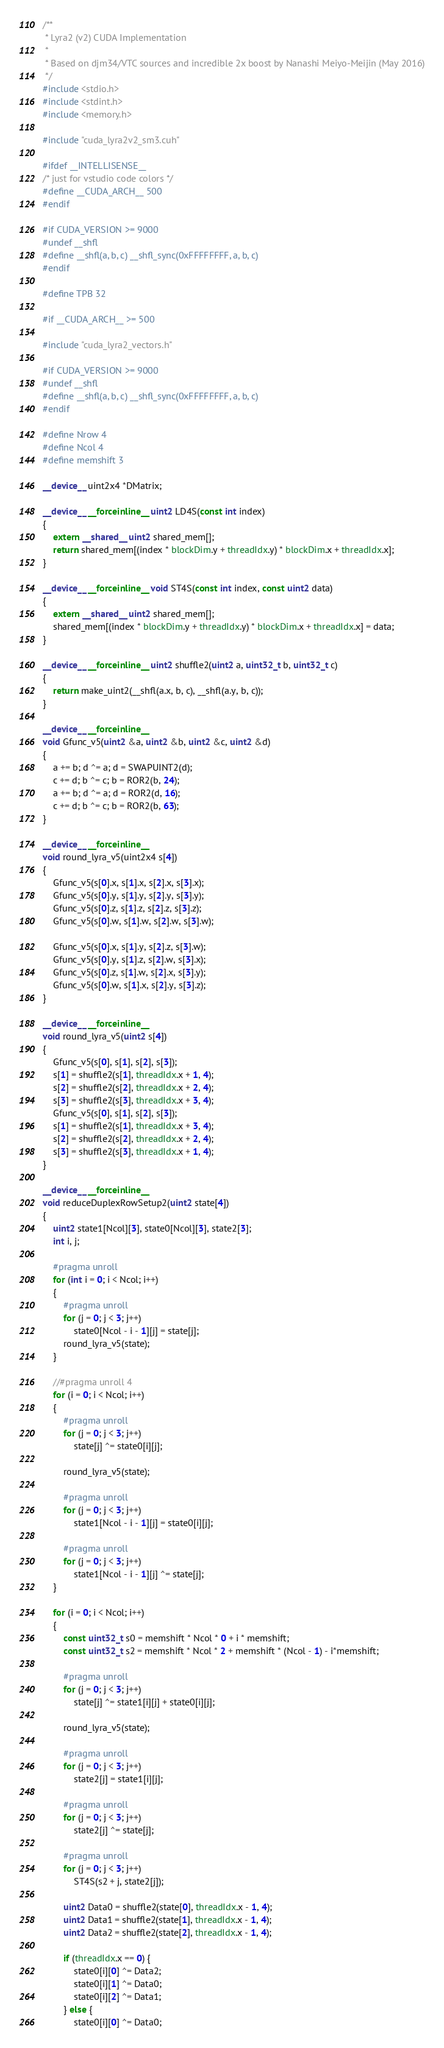Convert code to text. <code><loc_0><loc_0><loc_500><loc_500><_Cuda_>/**
 * Lyra2 (v2) CUDA Implementation
 *
 * Based on djm34/VTC sources and incredible 2x boost by Nanashi Meiyo-Meijin (May 2016)
 */
#include <stdio.h>
#include <stdint.h>
#include <memory.h>

#include "cuda_lyra2v2_sm3.cuh"

#ifdef __INTELLISENSE__
/* just for vstudio code colors */
#define __CUDA_ARCH__ 500
#endif

#if CUDA_VERSION >= 9000
#undef __shfl
#define __shfl(a, b, c) __shfl_sync(0xFFFFFFFF, a, b, c)
#endif

#define TPB 32

#if __CUDA_ARCH__ >= 500

#include "cuda_lyra2_vectors.h"

#if CUDA_VERSION >= 9000
#undef __shfl
#define __shfl(a, b, c) __shfl_sync(0xFFFFFFFF, a, b, c)
#endif

#define Nrow 4
#define Ncol 4
#define memshift 3

__device__ uint2x4 *DMatrix;

__device__ __forceinline__ uint2 LD4S(const int index)
{
	extern __shared__ uint2 shared_mem[];
	return shared_mem[(index * blockDim.y + threadIdx.y) * blockDim.x + threadIdx.x];
}

__device__ __forceinline__ void ST4S(const int index, const uint2 data)
{
	extern __shared__ uint2 shared_mem[];
	shared_mem[(index * blockDim.y + threadIdx.y) * blockDim.x + threadIdx.x] = data;
}

__device__ __forceinline__ uint2 shuffle2(uint2 a, uint32_t b, uint32_t c)
{
	return make_uint2(__shfl(a.x, b, c), __shfl(a.y, b, c));
}

__device__ __forceinline__
void Gfunc_v5(uint2 &a, uint2 &b, uint2 &c, uint2 &d)
{
	a += b; d ^= a; d = SWAPUINT2(d);
	c += d; b ^= c; b = ROR2(b, 24);
	a += b; d ^= a; d = ROR2(d, 16);
	c += d; b ^= c; b = ROR2(b, 63);
}

__device__ __forceinline__
void round_lyra_v5(uint2x4 s[4])
{
	Gfunc_v5(s[0].x, s[1].x, s[2].x, s[3].x);
	Gfunc_v5(s[0].y, s[1].y, s[2].y, s[3].y);
	Gfunc_v5(s[0].z, s[1].z, s[2].z, s[3].z);
	Gfunc_v5(s[0].w, s[1].w, s[2].w, s[3].w);

	Gfunc_v5(s[0].x, s[1].y, s[2].z, s[3].w);
	Gfunc_v5(s[0].y, s[1].z, s[2].w, s[3].x);
	Gfunc_v5(s[0].z, s[1].w, s[2].x, s[3].y);
	Gfunc_v5(s[0].w, s[1].x, s[2].y, s[3].z);
}

__device__ __forceinline__
void round_lyra_v5(uint2 s[4])
{
	Gfunc_v5(s[0], s[1], s[2], s[3]);
	s[1] = shuffle2(s[1], threadIdx.x + 1, 4);
	s[2] = shuffle2(s[2], threadIdx.x + 2, 4);
	s[3] = shuffle2(s[3], threadIdx.x + 3, 4);
	Gfunc_v5(s[0], s[1], s[2], s[3]);
	s[1] = shuffle2(s[1], threadIdx.x + 3, 4);
	s[2] = shuffle2(s[2], threadIdx.x + 2, 4);
	s[3] = shuffle2(s[3], threadIdx.x + 1, 4);
}

__device__ __forceinline__
void reduceDuplexRowSetup2(uint2 state[4])
{
	uint2 state1[Ncol][3], state0[Ncol][3], state2[3];
	int i, j;

	#pragma unroll
	for (int i = 0; i < Ncol; i++)
	{
		#pragma unroll
		for (j = 0; j < 3; j++)
			state0[Ncol - i - 1][j] = state[j];
		round_lyra_v5(state);
	}

	//#pragma unroll 4
	for (i = 0; i < Ncol; i++)
	{
		#pragma unroll
		for (j = 0; j < 3; j++)
			state[j] ^= state0[i][j];

		round_lyra_v5(state);

		#pragma unroll
		for (j = 0; j < 3; j++)
			state1[Ncol - i - 1][j] = state0[i][j];

		#pragma unroll
		for (j = 0; j < 3; j++)
			state1[Ncol - i - 1][j] ^= state[j];
	}

	for (i = 0; i < Ncol; i++)
	{
		const uint32_t s0 = memshift * Ncol * 0 + i * memshift;
		const uint32_t s2 = memshift * Ncol * 2 + memshift * (Ncol - 1) - i*memshift;

		#pragma unroll
		for (j = 0; j < 3; j++)
			state[j] ^= state1[i][j] + state0[i][j];

		round_lyra_v5(state);

		#pragma unroll
		for (j = 0; j < 3; j++)
			state2[j] = state1[i][j];

		#pragma unroll
		for (j = 0; j < 3; j++)
			state2[j] ^= state[j];

		#pragma unroll
		for (j = 0; j < 3; j++)
			ST4S(s2 + j, state2[j]);

		uint2 Data0 = shuffle2(state[0], threadIdx.x - 1, 4);
		uint2 Data1 = shuffle2(state[1], threadIdx.x - 1, 4);
		uint2 Data2 = shuffle2(state[2], threadIdx.x - 1, 4);

		if (threadIdx.x == 0) {
			state0[i][0] ^= Data2;
			state0[i][1] ^= Data0;
			state0[i][2] ^= Data1;
		} else {
			state0[i][0] ^= Data0;</code> 